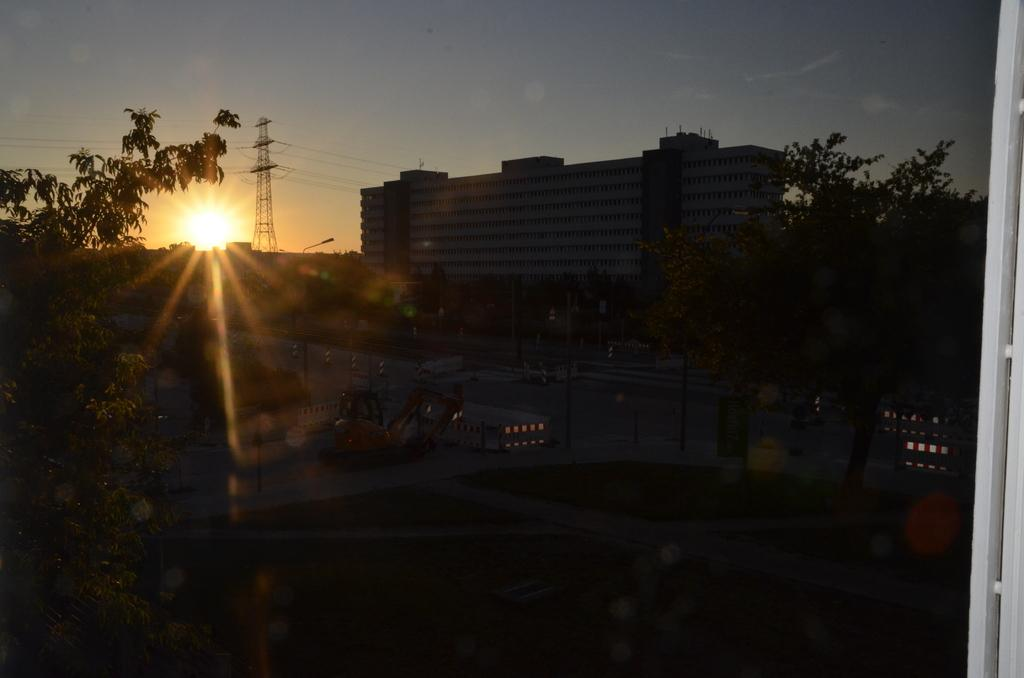What object is present in the image that has a transparent surface? There is a glass in the image. What can be seen through the glass in the image? Trees and buildings are visible through the glass. What is the purpose of the electric pole in the image? The electric pole supports wires in the image. What is the weather like in the image? The sun is visible in the sky, suggesting a clear day. What type of act can be heard being performed in the image? There is no audible act being performed in the image, as it is a still image. What is the need for the wires in the image? The wires in the image are not associated with a specific need, as they are simply part of the infrastructure. 